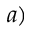Convert formula to latex. <formula><loc_0><loc_0><loc_500><loc_500>a )</formula> 